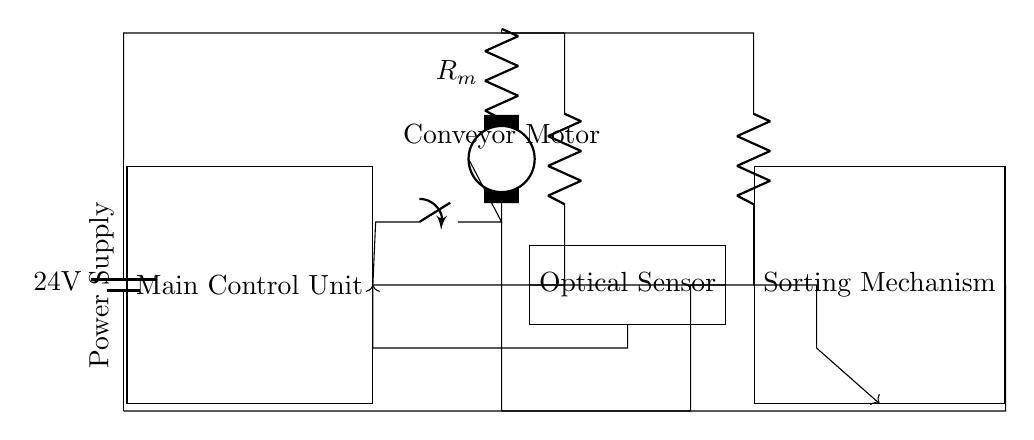What is the voltage of this circuit? The voltage is 24 volts, indicated by the label of the battery which powers the entire circuit.
Answer: 24 volts What is the function of the optical sensor in this circuit? The optical sensor detects brass casings as they pass by, sending signals to the main control unit for sorting purposes.
Answer: Detection What component is used for the main control unit? The main control unit is represented by a rectangular block labeled as "Main Control Unit" in the circuit.
Answer: Main Control Unit How many main components are there in this circuit? There are three main components: the main control unit, the conveyor motor, and the sorting mechanism.
Answer: Three What is the operational relationship between the optical sensor and the main control unit? The optical sensor sends signals to the main control unit based on the detection of brass casings, which allows the MCU to control the motors accordingly.
Answer: Signal control What type of motor is used in this circuit? A conveyor motor is used, specifically designed to move the brass casings along the sorting line.
Answer: Conveyor motor What is the directional flow of power from the battery? The direction of power flow starts from the battery at the top, supplying power to the motor and other components as shown in the connections.
Answer: From battery to components 